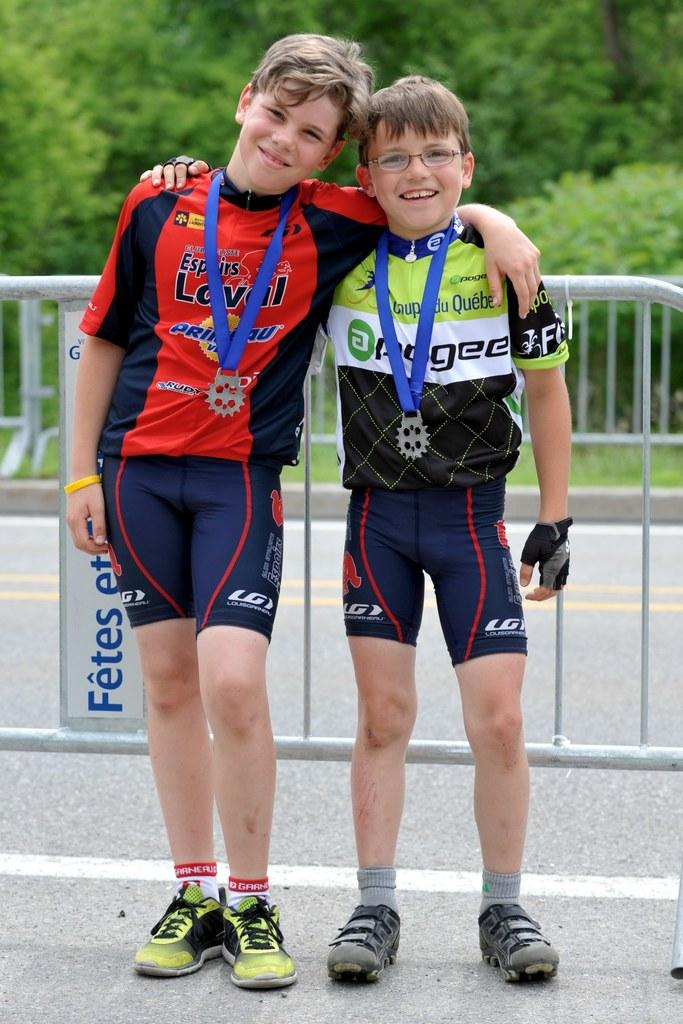Provide a one-sentence caption for the provided image. A young athlete poses with a friend while wearing Garneau socks. 